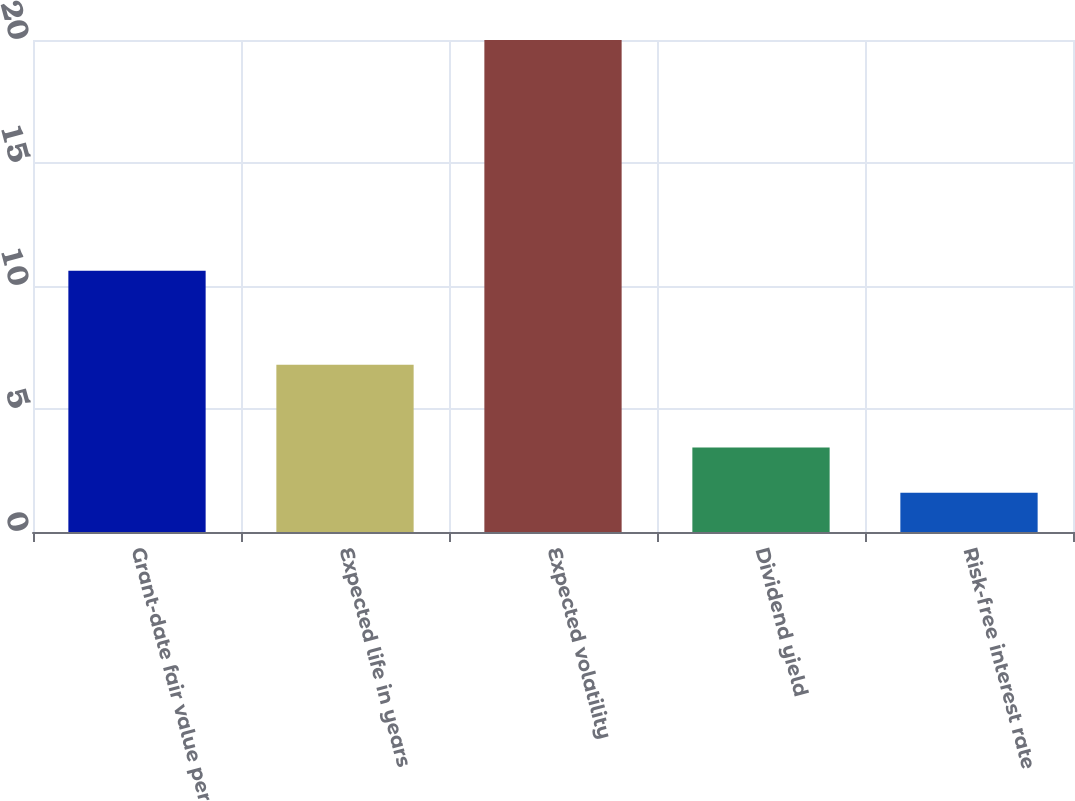Convert chart. <chart><loc_0><loc_0><loc_500><loc_500><bar_chart><fcel>Grant-date fair value per<fcel>Expected life in years<fcel>Expected volatility<fcel>Dividend yield<fcel>Risk-free interest rate<nl><fcel>10.62<fcel>6.8<fcel>20<fcel>3.44<fcel>1.6<nl></chart> 